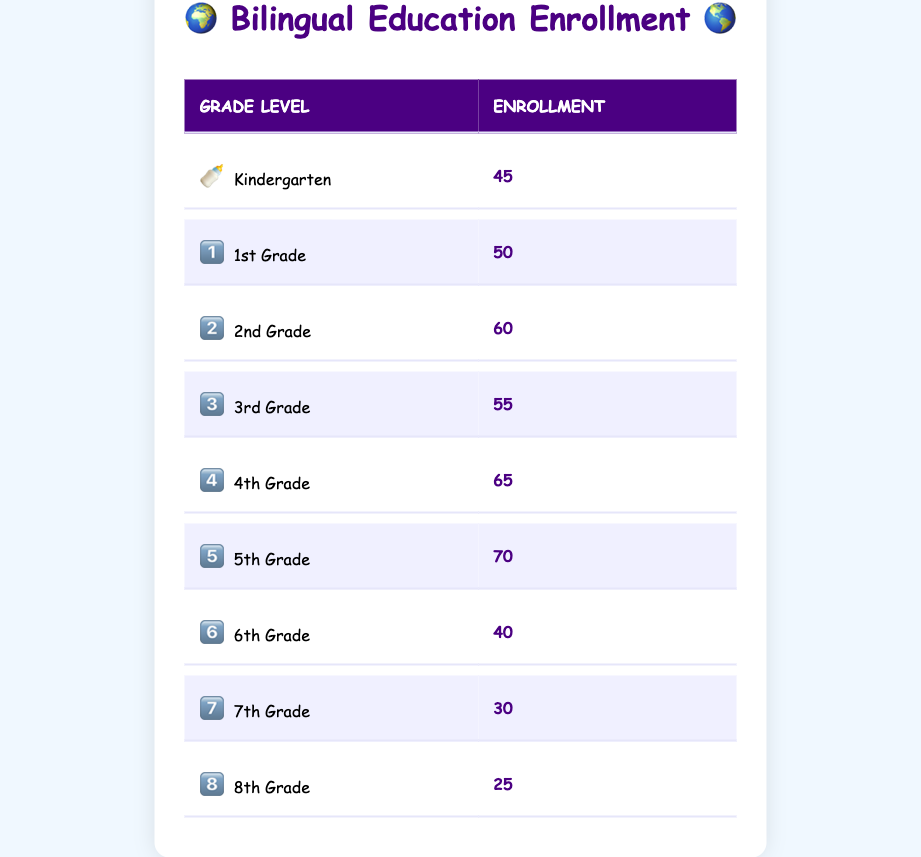What is the total enrollment in the Bilingual Education Program? To find the total enrollment, we need to sum the enrollment figures from all grade levels: 45 + 50 + 60 + 55 + 65 + 70 + 40 + 30 + 25 = 400.
Answer: 400 Which grade level has the highest enrollment? Scanning through the enrollment numbers, the highest figure is 70, which corresponds to the 5th Grade.
Answer: 5th Grade Is the enrollment for Kindergarten greater than that for 8th Grade? The enrollment for Kindergarten is 45, while for 8th Grade it is 25. Since 45 is greater than 25, the statement is true.
Answer: Yes What is the average enrollment across all grades? To calculate the average, we take the total enrollment (400) and divide it by the number of grade levels (9): 400 / 9 = 44.44.
Answer: 44.44 How many more students are enrolled in 4th Grade than in 6th Grade? The enrollment for 4th Grade is 65, and for 6th Grade it is 40. Subtracting these gives 65 - 40 = 25 more students in 4th Grade than in 6th Grade.
Answer: 25 Are there more students enrolled in 1st Grade or 3rd Grade? The enrollment for 1st Grade is 50, while for 3rd Grade it is 55. Since 55 is greater than 50, there are more students in 3rd Grade.
Answer: 3rd Grade What percentage of the total enrollment is comprised of 2nd Grade students? To find the percentage, we divide the enrollment of 2nd Grade (60) by the total enrollment (400), then multiply by 100: (60 / 400) * 100 = 15%.
Answer: 15% If we combine the enrollments of the 7th and 8th Grades, what is the total? Adding the enrollments: 30 (7th Grade) + 25 (8th Grade) = 55 students in total for both grades.
Answer: 55 Which grade levels have an enrollment of less than 50? Looking at the table, both 7th (30) and 8th Grade (25) have enrollments less than 50.
Answer: 7th and 8th Grade 